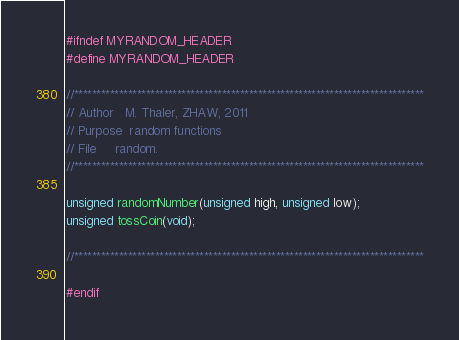<code> <loc_0><loc_0><loc_500><loc_500><_C_>#ifndef MYRANDOM_HEADER
#define MYRANDOM_HEADER

//******************************************************************************
// Author	M. Thaler, ZHAW, 2011
// Purpose	random functions
// File		random.
//******************************************************************************

unsigned randomNumber(unsigned high, unsigned low);
unsigned tossCoin(void);

//******************************************************************************

#endif
</code> 